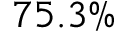<formula> <loc_0><loc_0><loc_500><loc_500>7 5 . 3 \%</formula> 